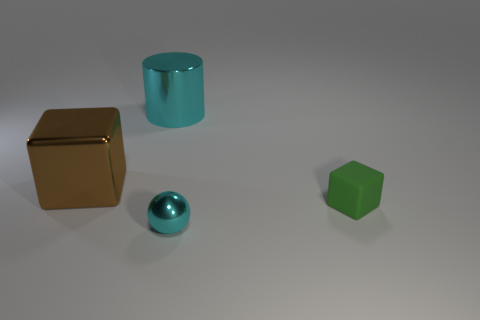Add 4 small green metal blocks. How many objects exist? 8 Add 3 large blocks. How many large blocks exist? 4 Subtract 0 brown spheres. How many objects are left? 4 Subtract all big red cylinders. Subtract all matte cubes. How many objects are left? 3 Add 3 brown shiny things. How many brown shiny things are left? 4 